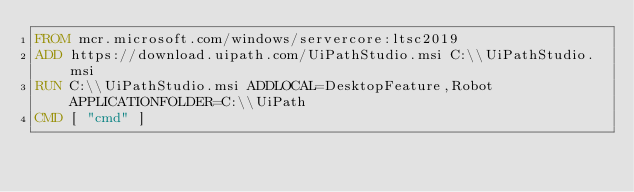<code> <loc_0><loc_0><loc_500><loc_500><_Dockerfile_>FROM mcr.microsoft.com/windows/servercore:ltsc2019
ADD https://download.uipath.com/UiPathStudio.msi C:\\UiPathStudio.msi 
RUN C:\\UiPathStudio.msi ADDLOCAL=DesktopFeature,Robot APPLICATIONFOLDER=C:\\UiPath
CMD [ "cmd" ]</code> 